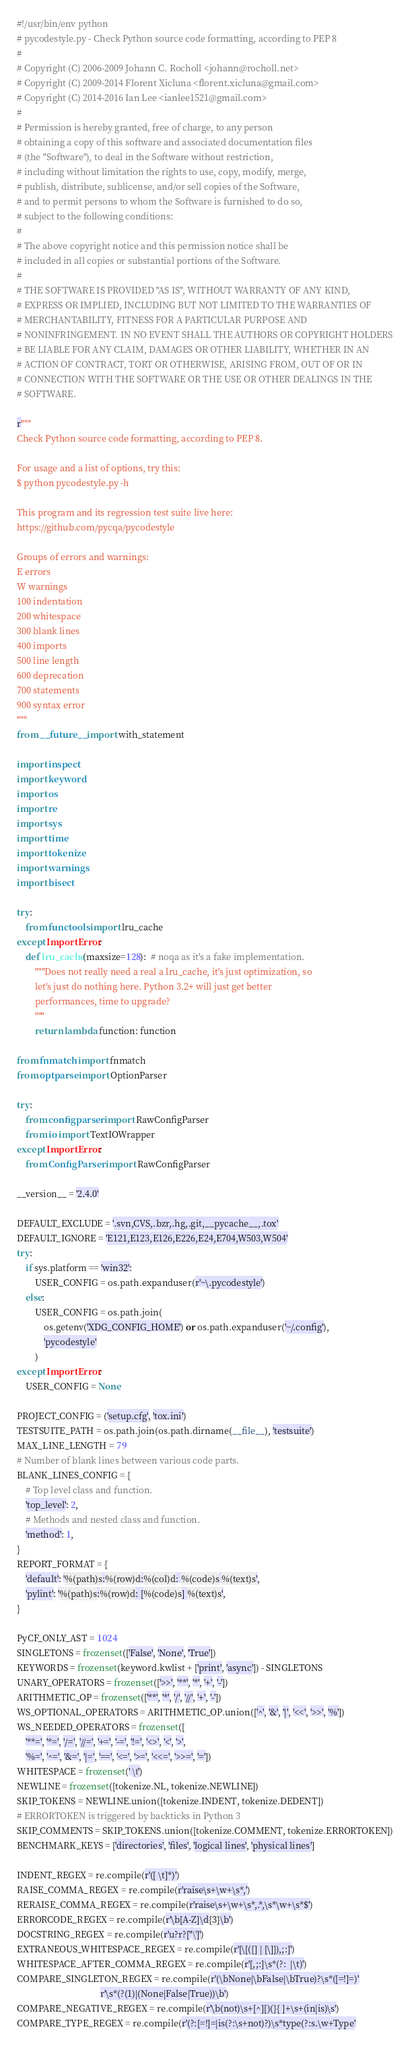<code> <loc_0><loc_0><loc_500><loc_500><_Python_>#!/usr/bin/env python
# pycodestyle.py - Check Python source code formatting, according to PEP 8
#
# Copyright (C) 2006-2009 Johann C. Rocholl <johann@rocholl.net>
# Copyright (C) 2009-2014 Florent Xicluna <florent.xicluna@gmail.com>
# Copyright (C) 2014-2016 Ian Lee <ianlee1521@gmail.com>
#
# Permission is hereby granted, free of charge, to any person
# obtaining a copy of this software and associated documentation files
# (the "Software"), to deal in the Software without restriction,
# including without limitation the rights to use, copy, modify, merge,
# publish, distribute, sublicense, and/or sell copies of the Software,
# and to permit persons to whom the Software is furnished to do so,
# subject to the following conditions:
#
# The above copyright notice and this permission notice shall be
# included in all copies or substantial portions of the Software.
#
# THE SOFTWARE IS PROVIDED "AS IS", WITHOUT WARRANTY OF ANY KIND,
# EXPRESS OR IMPLIED, INCLUDING BUT NOT LIMITED TO THE WARRANTIES OF
# MERCHANTABILITY, FITNESS FOR A PARTICULAR PURPOSE AND
# NONINFRINGEMENT. IN NO EVENT SHALL THE AUTHORS OR COPYRIGHT HOLDERS
# BE LIABLE FOR ANY CLAIM, DAMAGES OR OTHER LIABILITY, WHETHER IN AN
# ACTION OF CONTRACT, TORT OR OTHERWISE, ARISING FROM, OUT OF OR IN
# CONNECTION WITH THE SOFTWARE OR THE USE OR OTHER DEALINGS IN THE
# SOFTWARE.

r"""
Check Python source code formatting, according to PEP 8.

For usage and a list of options, try this:
$ python pycodestyle.py -h

This program and its regression test suite live here:
https://github.com/pycqa/pycodestyle

Groups of errors and warnings:
E errors
W warnings
100 indentation
200 whitespace
300 blank lines
400 imports
500 line length
600 deprecation
700 statements
900 syntax error
"""
from __future__ import with_statement

import inspect
import keyword
import os
import re
import sys
import time
import tokenize
import warnings
import bisect

try:
    from functools import lru_cache
except ImportError:
    def lru_cache(maxsize=128):  # noqa as it's a fake implementation.
        """Does not really need a real a lru_cache, it's just optimization, so
        let's just do nothing here. Python 3.2+ will just get better
        performances, time to upgrade?
        """
        return lambda function: function

from fnmatch import fnmatch
from optparse import OptionParser

try:
    from configparser import RawConfigParser
    from io import TextIOWrapper
except ImportError:
    from ConfigParser import RawConfigParser

__version__ = '2.4.0'

DEFAULT_EXCLUDE = '.svn,CVS,.bzr,.hg,.git,__pycache__,.tox'
DEFAULT_IGNORE = 'E121,E123,E126,E226,E24,E704,W503,W504'
try:
    if sys.platform == 'win32':
        USER_CONFIG = os.path.expanduser(r'~\.pycodestyle')
    else:
        USER_CONFIG = os.path.join(
            os.getenv('XDG_CONFIG_HOME') or os.path.expanduser('~/.config'),
            'pycodestyle'
        )
except ImportError:
    USER_CONFIG = None

PROJECT_CONFIG = ('setup.cfg', 'tox.ini')
TESTSUITE_PATH = os.path.join(os.path.dirname(__file__), 'testsuite')
MAX_LINE_LENGTH = 79
# Number of blank lines between various code parts.
BLANK_LINES_CONFIG = {
    # Top level class and function.
    'top_level': 2,
    # Methods and nested class and function.
    'method': 1,
}
REPORT_FORMAT = {
    'default': '%(path)s:%(row)d:%(col)d: %(code)s %(text)s',
    'pylint': '%(path)s:%(row)d: [%(code)s] %(text)s',
}

PyCF_ONLY_AST = 1024
SINGLETONS = frozenset(['False', 'None', 'True'])
KEYWORDS = frozenset(keyword.kwlist + ['print', 'async']) - SINGLETONS
UNARY_OPERATORS = frozenset(['>>', '**', '*', '+', '-'])
ARITHMETIC_OP = frozenset(['**', '*', '/', '//', '+', '-'])
WS_OPTIONAL_OPERATORS = ARITHMETIC_OP.union(['^', '&', '|', '<<', '>>', '%'])
WS_NEEDED_OPERATORS = frozenset([
    '**=', '*=', '/=', '//=', '+=', '-=', '!=', '<>', '<', '>',
    '%=', '^=', '&=', '|=', '==', '<=', '>=', '<<=', '>>=', '='])
WHITESPACE = frozenset(' \t')
NEWLINE = frozenset([tokenize.NL, tokenize.NEWLINE])
SKIP_TOKENS = NEWLINE.union([tokenize.INDENT, tokenize.DEDENT])
# ERRORTOKEN is triggered by backticks in Python 3
SKIP_COMMENTS = SKIP_TOKENS.union([tokenize.COMMENT, tokenize.ERRORTOKEN])
BENCHMARK_KEYS = ['directories', 'files', 'logical lines', 'physical lines']

INDENT_REGEX = re.compile(r'([ \t]*)')
RAISE_COMMA_REGEX = re.compile(r'raise\s+\w+\s*,')
RERAISE_COMMA_REGEX = re.compile(r'raise\s+\w+\s*,.*,\s*\w+\s*$')
ERRORCODE_REGEX = re.compile(r'\b[A-Z]\d{3}\b')
DOCSTRING_REGEX = re.compile(r'u?r?["\']')
EXTRANEOUS_WHITESPACE_REGEX = re.compile(r'[\[({] | [\]}),;:]')
WHITESPACE_AFTER_COMMA_REGEX = re.compile(r'[,;:]\s*(?:  |\t)')
COMPARE_SINGLETON_REGEX = re.compile(r'(\bNone|\bFalse|\bTrue)?\s*([=!]=)'
                                     r'\s*(?(1)|(None|False|True))\b')
COMPARE_NEGATIVE_REGEX = re.compile(r'\b(not)\s+[^][)(}{ ]+\s+(in|is)\s')
COMPARE_TYPE_REGEX = re.compile(r'(?:[=!]=|is(?:\s+not)?)\s*type(?:s.\w+Type'</code> 